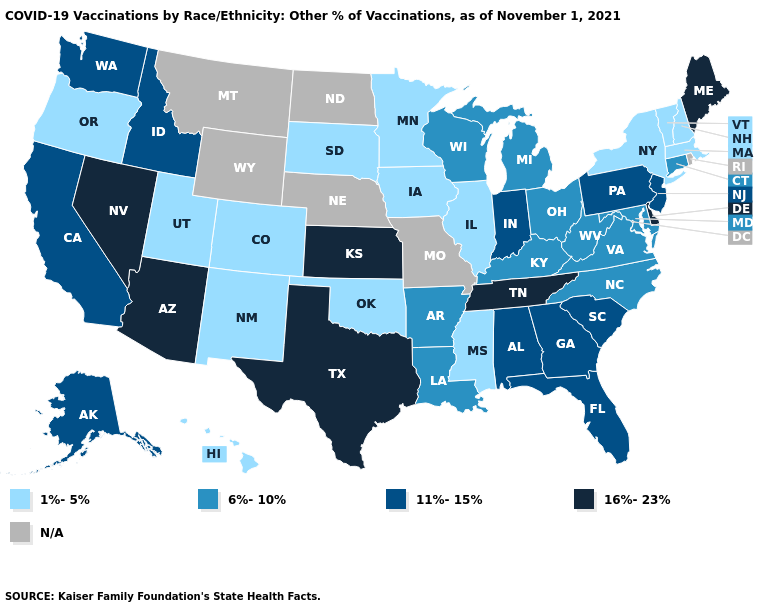What is the value of Kansas?
Give a very brief answer. 16%-23%. Does Wisconsin have the lowest value in the USA?
Short answer required. No. Name the states that have a value in the range 11%-15%?
Short answer required. Alabama, Alaska, California, Florida, Georgia, Idaho, Indiana, New Jersey, Pennsylvania, South Carolina, Washington. Name the states that have a value in the range 6%-10%?
Give a very brief answer. Arkansas, Connecticut, Kentucky, Louisiana, Maryland, Michigan, North Carolina, Ohio, Virginia, West Virginia, Wisconsin. Which states have the lowest value in the MidWest?
Concise answer only. Illinois, Iowa, Minnesota, South Dakota. Which states hav the highest value in the MidWest?
Concise answer only. Kansas. Among the states that border Texas , which have the lowest value?
Give a very brief answer. New Mexico, Oklahoma. Among the states that border New Jersey , does Pennsylvania have the highest value?
Quick response, please. No. What is the lowest value in states that border North Carolina?
Write a very short answer. 6%-10%. Among the states that border Louisiana , which have the lowest value?
Quick response, please. Mississippi. What is the highest value in the South ?
Keep it brief. 16%-23%. What is the value of New York?
Write a very short answer. 1%-5%. Name the states that have a value in the range N/A?
Short answer required. Missouri, Montana, Nebraska, North Dakota, Rhode Island, Wyoming. How many symbols are there in the legend?
Write a very short answer. 5. Does Tennessee have the highest value in the South?
Concise answer only. Yes. 